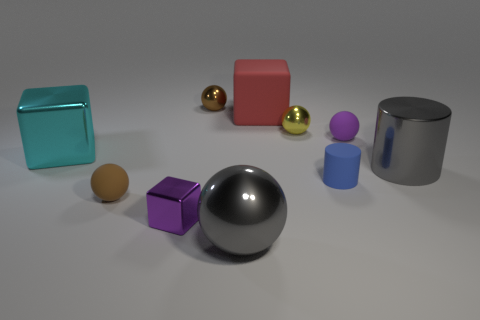Subtract all small purple blocks. How many blocks are left? 2 Subtract all purple spheres. How many spheres are left? 4 Subtract 1 cylinders. How many cylinders are left? 1 Subtract all yellow blocks. Subtract all green balls. How many blocks are left? 3 Subtract all cyan cylinders. How many cyan blocks are left? 1 Subtract all cyan metal blocks. Subtract all small cubes. How many objects are left? 8 Add 3 small blue cylinders. How many small blue cylinders are left? 4 Add 5 cyan metallic cylinders. How many cyan metallic cylinders exist? 5 Subtract 0 gray cubes. How many objects are left? 10 Subtract all cubes. How many objects are left? 7 